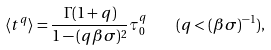<formula> <loc_0><loc_0><loc_500><loc_500>\langle t ^ { q } \rangle = \frac { \Gamma ( 1 + q ) } { 1 - ( q \beta \sigma ) ^ { 2 } } \tau _ { 0 } ^ { q } \quad ( q < ( \beta \sigma ) ^ { - 1 } ) ,</formula> 